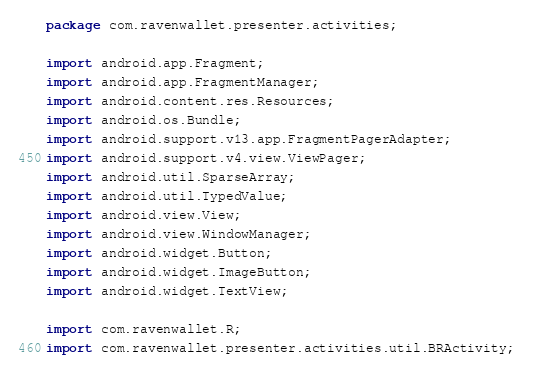<code> <loc_0><loc_0><loc_500><loc_500><_Java_>package com.ravenwallet.presenter.activities;

import android.app.Fragment;
import android.app.FragmentManager;
import android.content.res.Resources;
import android.os.Bundle;
import android.support.v13.app.FragmentPagerAdapter;
import android.support.v4.view.ViewPager;
import android.util.SparseArray;
import android.util.TypedValue;
import android.view.View;
import android.view.WindowManager;
import android.widget.Button;
import android.widget.ImageButton;
import android.widget.TextView;

import com.ravenwallet.R;
import com.ravenwallet.presenter.activities.util.BRActivity;</code> 